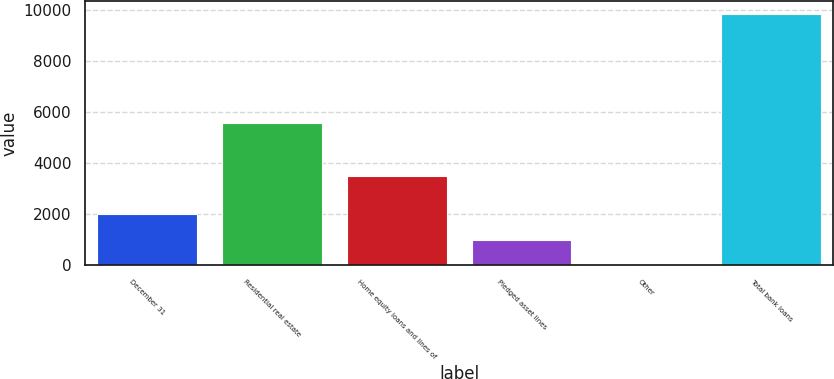Convert chart. <chart><loc_0><loc_0><loc_500><loc_500><bar_chart><fcel>December 31<fcel>Residential real estate<fcel>Home equity loans and lines of<fcel>Pledged asset lines<fcel>Other<fcel>Total bank loans<nl><fcel>2011<fcel>5596<fcel>3509<fcel>1000.7<fcel>16<fcel>9863<nl></chart> 